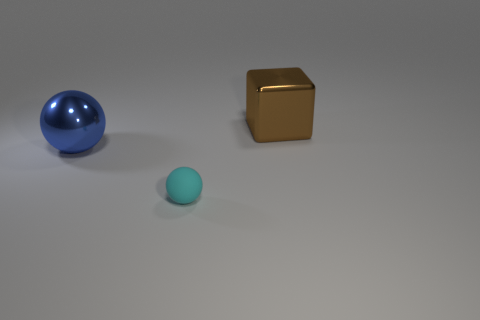Can you tell the time of day or location from the image? The image doesn't provide explicit details about the time of day or location. The uniform lighting and the lack of contextual elements suggest this might be an indoor scene, perhaps in a controlled setting like a studio where the primary focus is the objects themselves. 